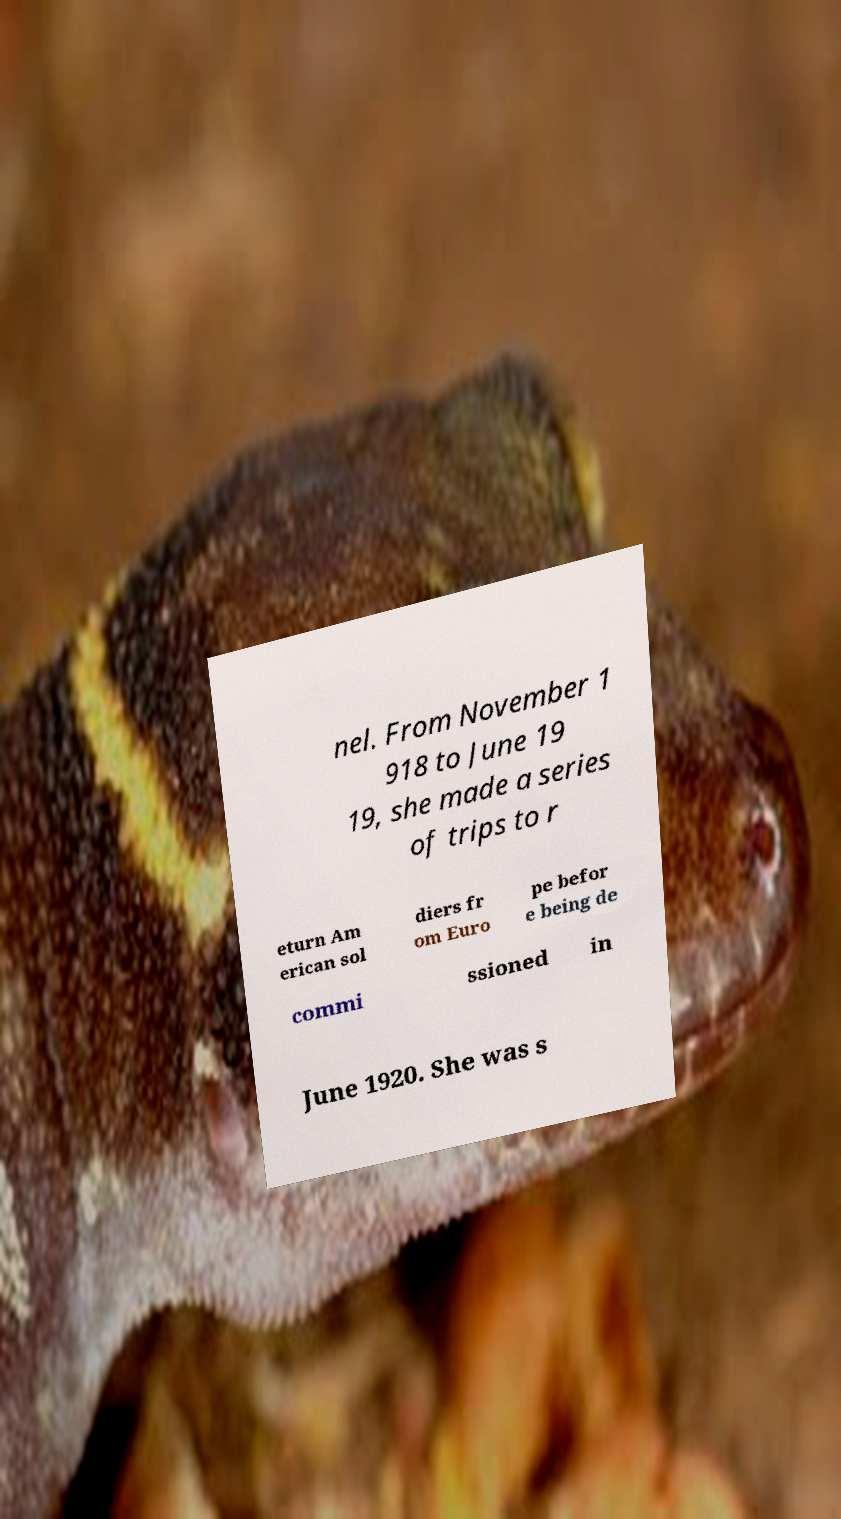Can you read and provide the text displayed in the image?This photo seems to have some interesting text. Can you extract and type it out for me? nel. From November 1 918 to June 19 19, she made a series of trips to r eturn Am erican sol diers fr om Euro pe befor e being de commi ssioned in June 1920. She was s 